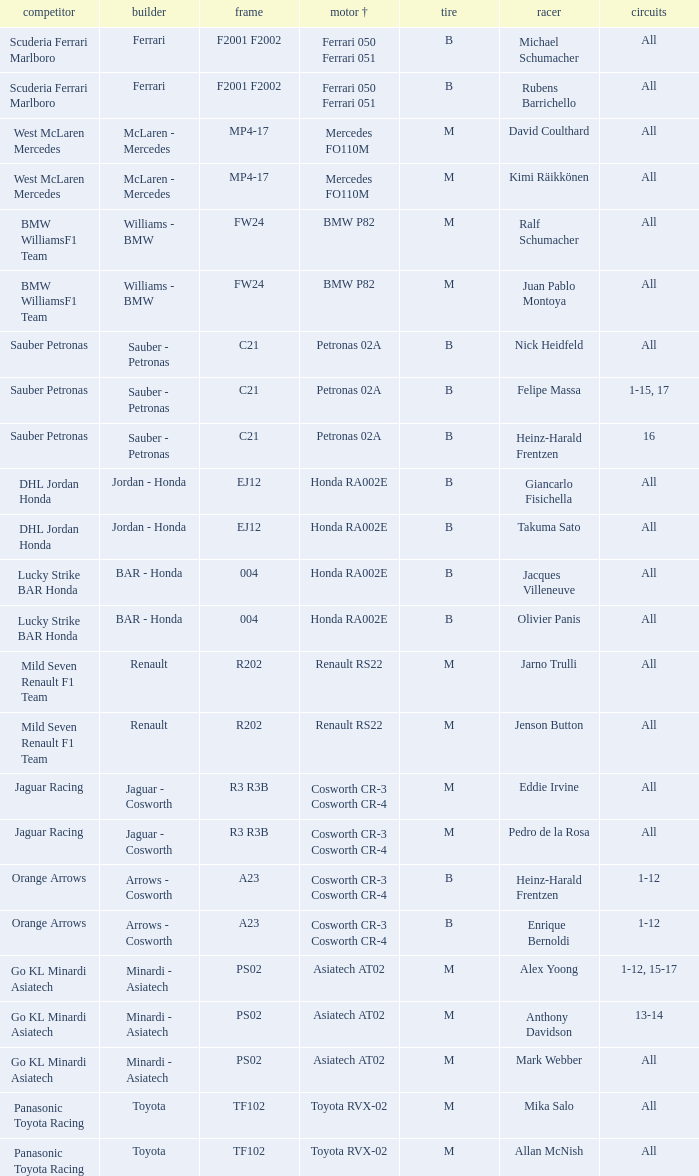What is the tire when the motor is asiatech at02 and the pilot is alex yoong? M. 